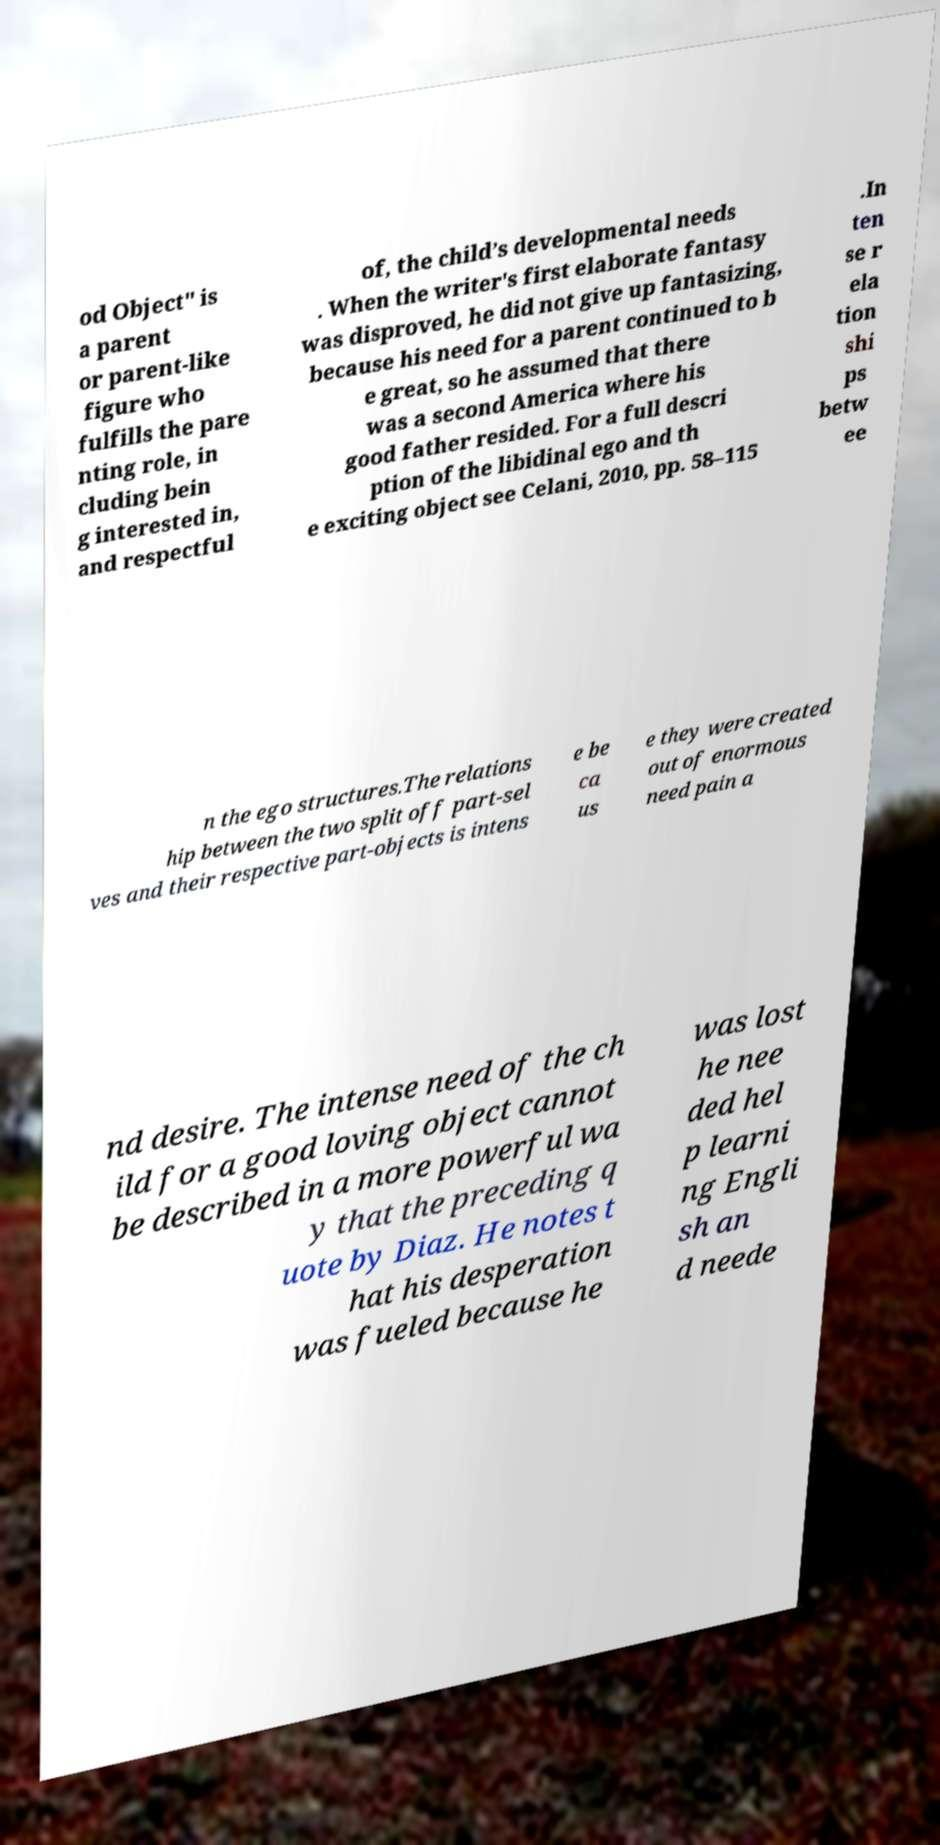Could you assist in decoding the text presented in this image and type it out clearly? od Object" is a parent or parent-like figure who fulfills the pare nting role, in cluding bein g interested in, and respectful of, the child’s developmental needs . When the writer's first elaborate fantasy was disproved, he did not give up fantasizing, because his need for a parent continued to b e great, so he assumed that there was a second America where his good father resided. For a full descri ption of the libidinal ego and th e exciting object see Celani, 2010, pp. 58–115 .In ten se r ela tion shi ps betw ee n the ego structures.The relations hip between the two split off part-sel ves and their respective part-objects is intens e be ca us e they were created out of enormous need pain a nd desire. The intense need of the ch ild for a good loving object cannot be described in a more powerful wa y that the preceding q uote by Diaz. He notes t hat his desperation was fueled because he was lost he nee ded hel p learni ng Engli sh an d neede 